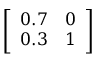Convert formula to latex. <formula><loc_0><loc_0><loc_500><loc_500>\left [ \begin{array} { l l } { 0 . 7 } & { 0 } \\ { 0 . 3 } & { 1 } \end{array} \right ]</formula> 